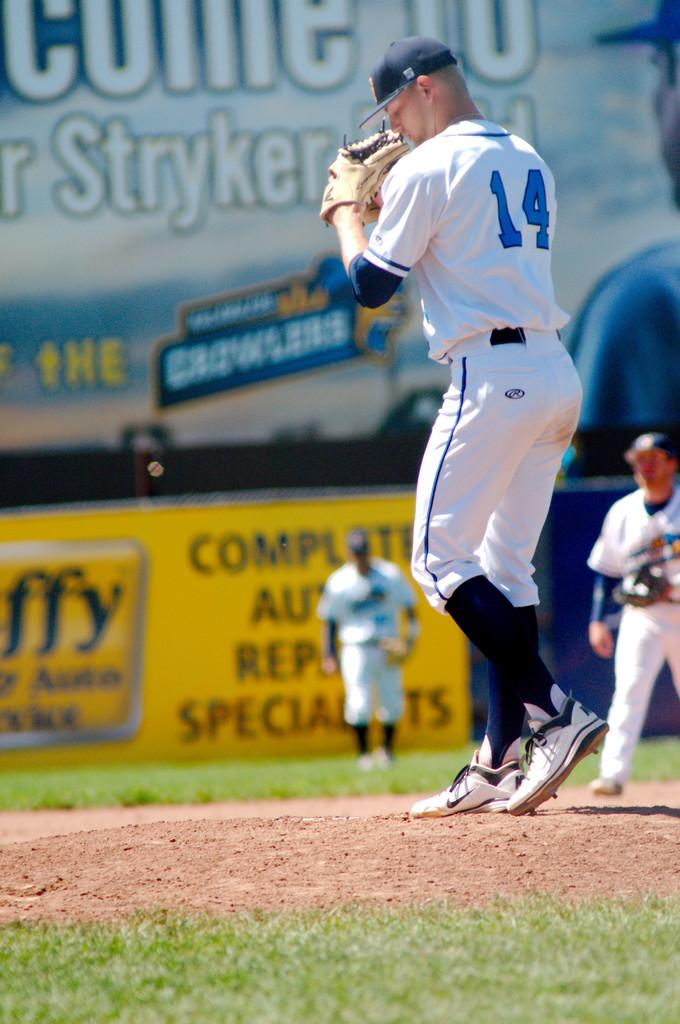<image>
Summarize the visual content of the image. An intense baseball pitcher wears the number 14 uniform. 